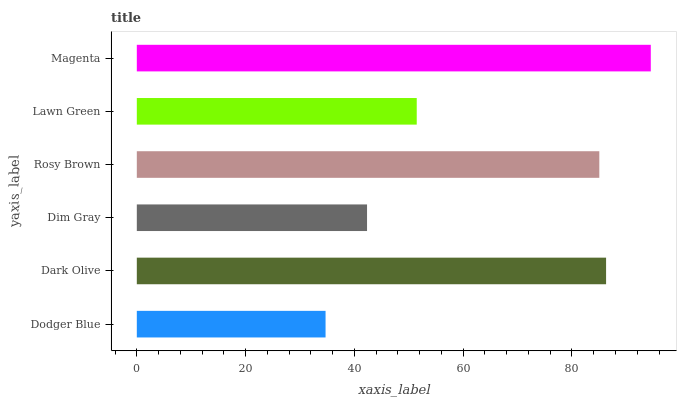Is Dodger Blue the minimum?
Answer yes or no. Yes. Is Magenta the maximum?
Answer yes or no. Yes. Is Dark Olive the minimum?
Answer yes or no. No. Is Dark Olive the maximum?
Answer yes or no. No. Is Dark Olive greater than Dodger Blue?
Answer yes or no. Yes. Is Dodger Blue less than Dark Olive?
Answer yes or no. Yes. Is Dodger Blue greater than Dark Olive?
Answer yes or no. No. Is Dark Olive less than Dodger Blue?
Answer yes or no. No. Is Rosy Brown the high median?
Answer yes or no. Yes. Is Lawn Green the low median?
Answer yes or no. Yes. Is Dodger Blue the high median?
Answer yes or no. No. Is Dark Olive the low median?
Answer yes or no. No. 